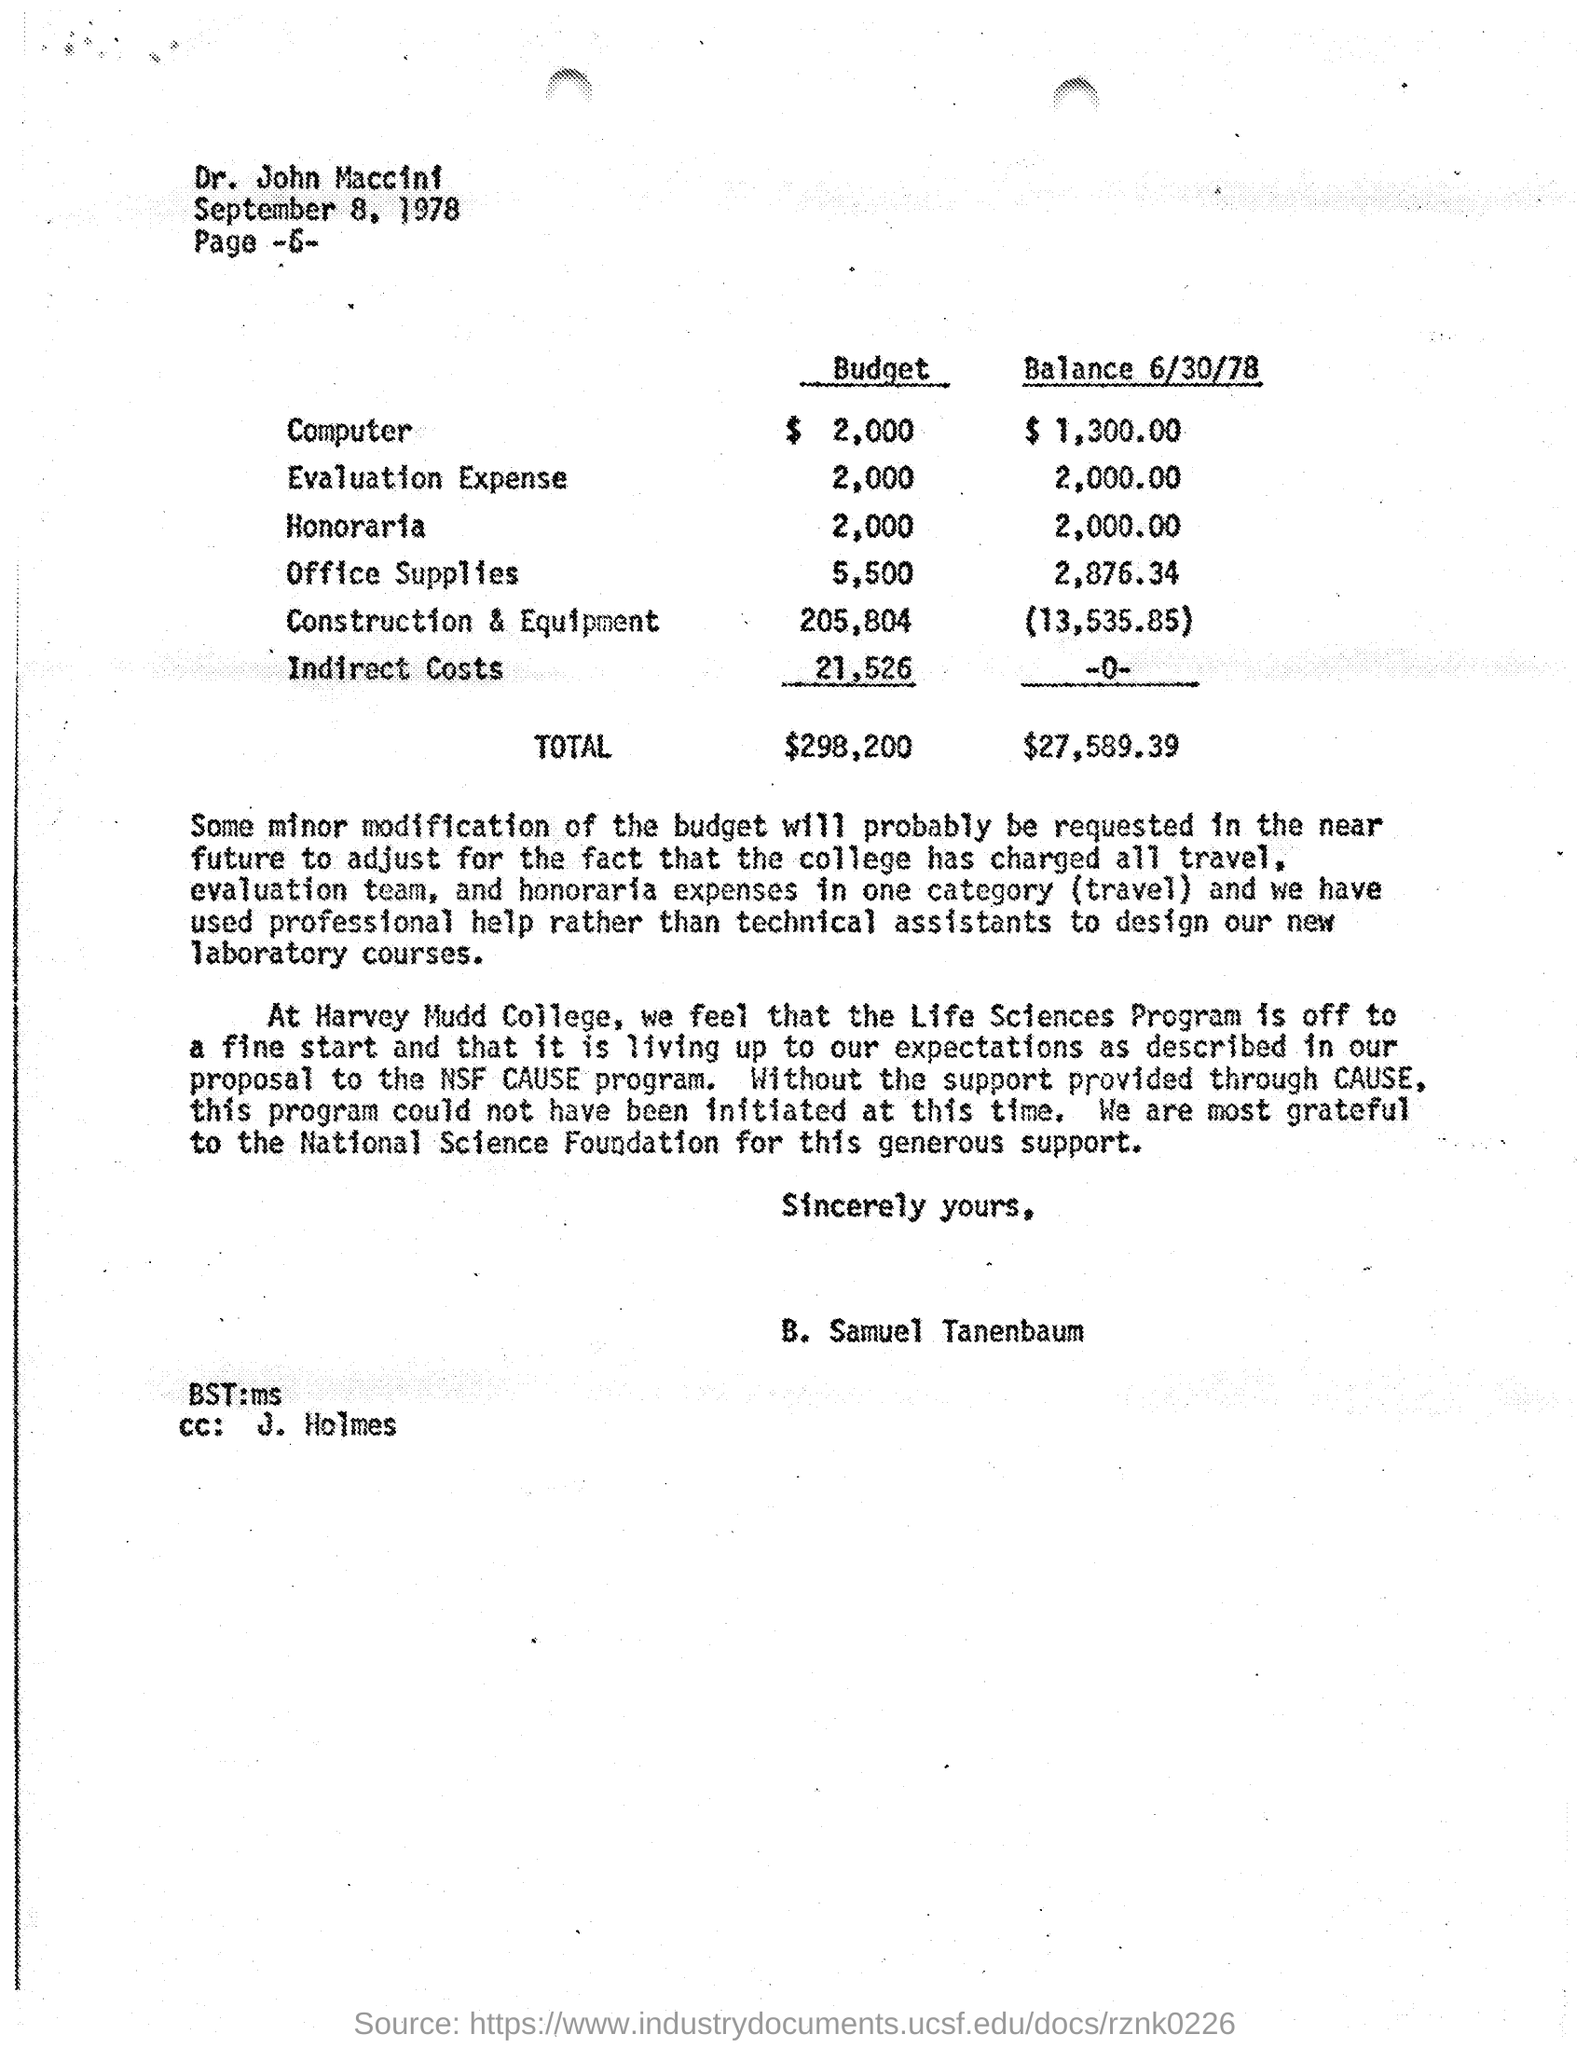When was this Printed?
Offer a terse response. September 8, 1978. What budget estimated for Honoraria?
Give a very brief answer. 2,000. Who send this estimate to dr.john maccini?
Ensure brevity in your answer.  B. Samuel tanenbaum. What's the college name mentioned?
Provide a succinct answer. Harvey mudd college. What is the Program to be Started?
Your answer should be compact. Life Science Program. Who supported the college  for the program?
Ensure brevity in your answer.  National Science Foundation. Whats the TOTAL Balance amount?
Provide a short and direct response. $27,589.39. How many dollars were estimated for Construction and Equipment?
Provide a short and direct response. $205,804. 